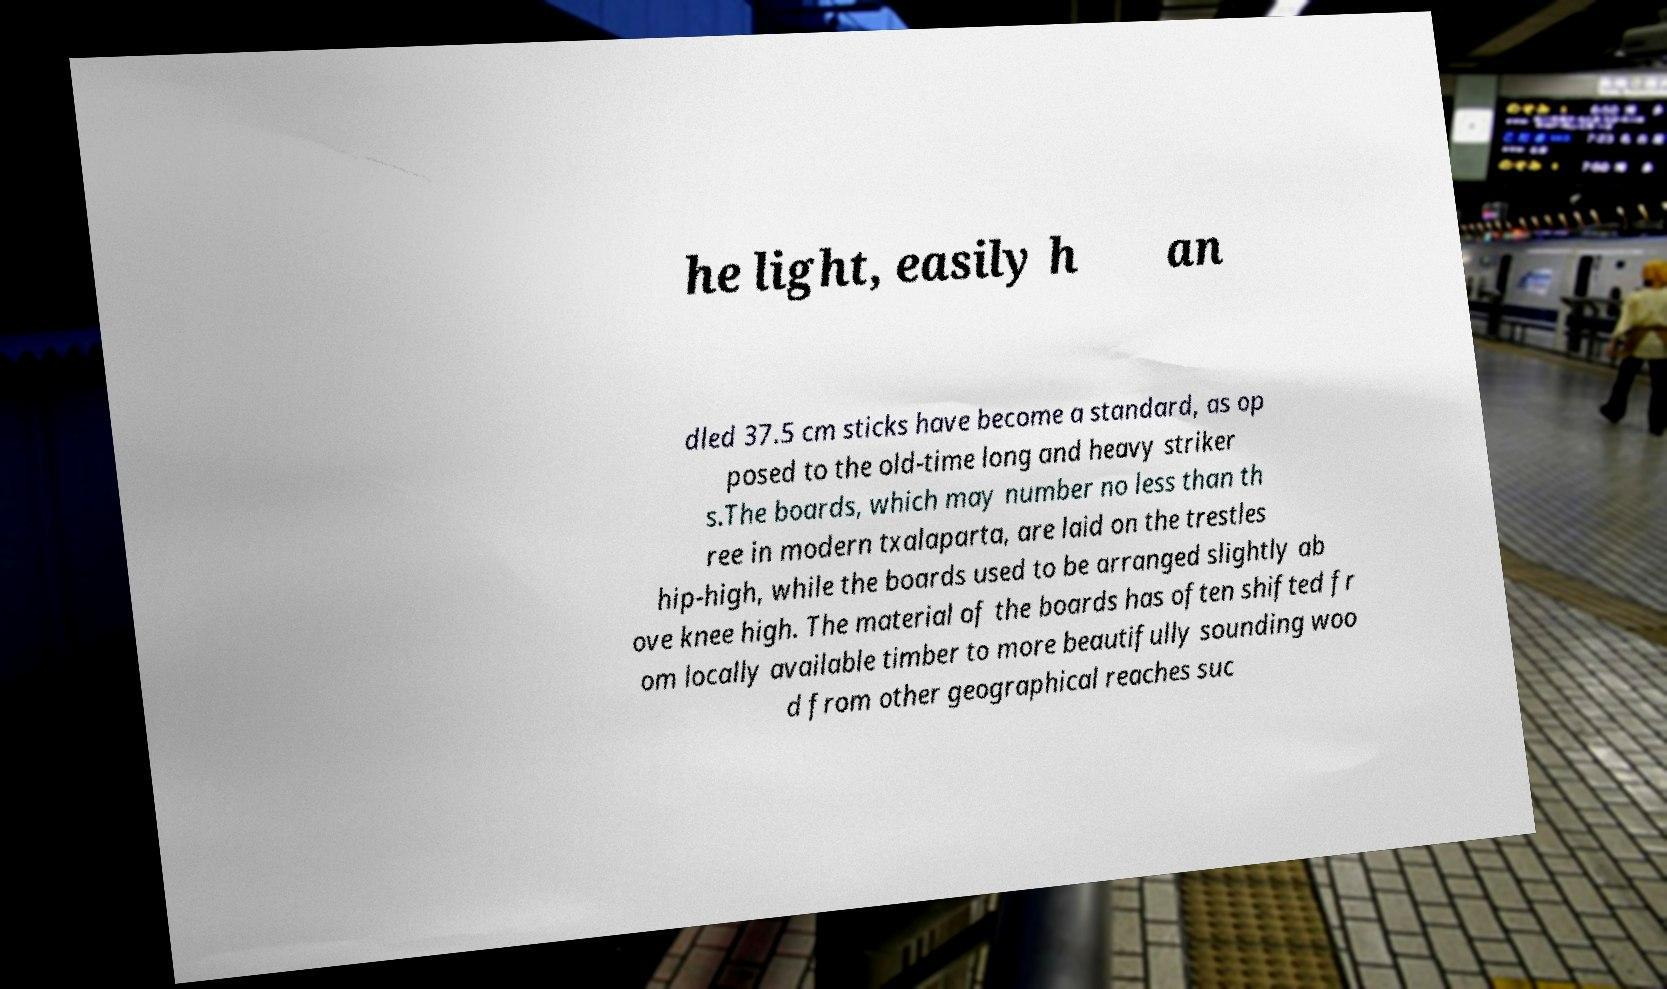Could you extract and type out the text from this image? he light, easily h an dled 37.5 cm sticks have become a standard, as op posed to the old-time long and heavy striker s.The boards, which may number no less than th ree in modern txalaparta, are laid on the trestles hip-high, while the boards used to be arranged slightly ab ove knee high. The material of the boards has often shifted fr om locally available timber to more beautifully sounding woo d from other geographical reaches suc 